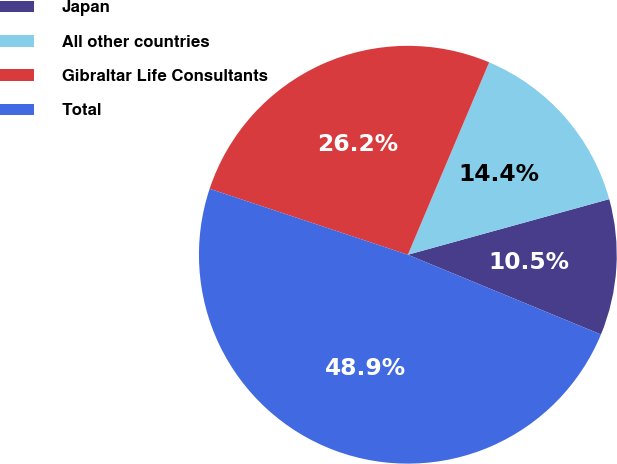Convert chart to OTSL. <chart><loc_0><loc_0><loc_500><loc_500><pie_chart><fcel>Japan<fcel>All other countries<fcel>Gibraltar Life Consultants<fcel>Total<nl><fcel>10.52%<fcel>14.35%<fcel>26.25%<fcel>48.88%<nl></chart> 